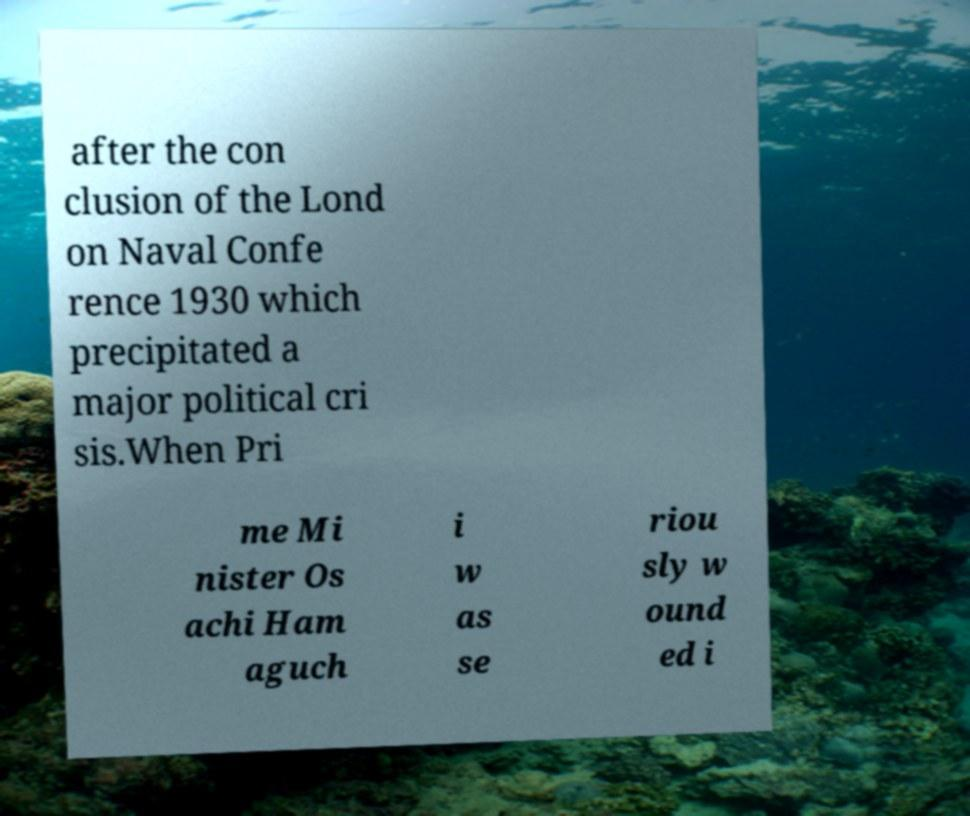I need the written content from this picture converted into text. Can you do that? after the con clusion of the Lond on Naval Confe rence 1930 which precipitated a major political cri sis.When Pri me Mi nister Os achi Ham aguch i w as se riou sly w ound ed i 